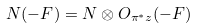<formula> <loc_0><loc_0><loc_500><loc_500>N ( - F ) = N \otimes O _ { \pi ^ { * } z } ( - F )</formula> 